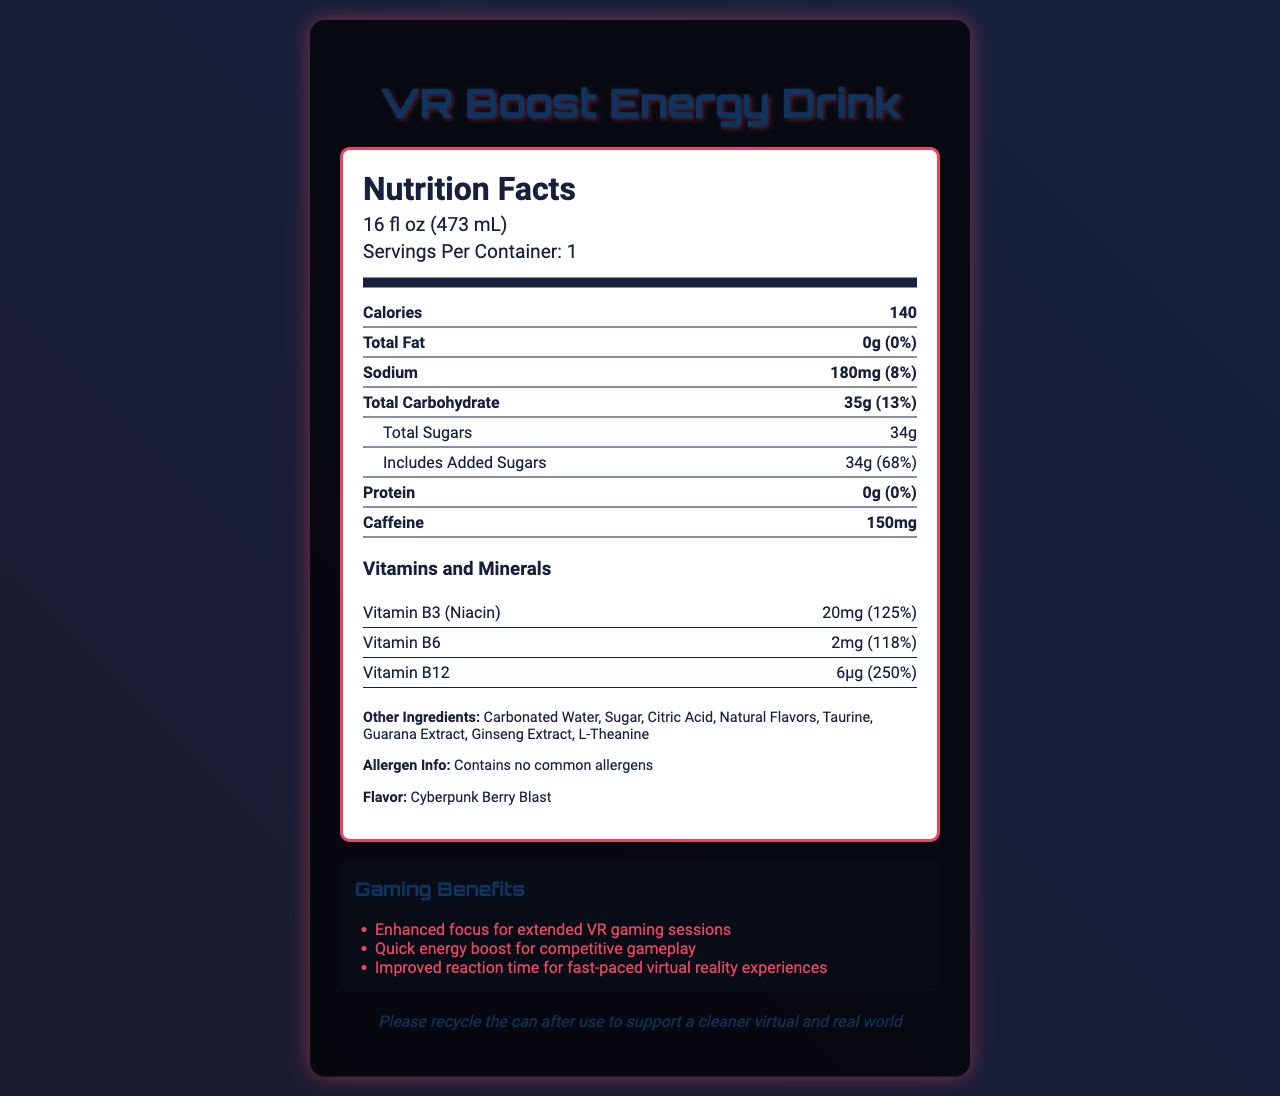who is the manufacturer of VR Boost Energy Drink? The document does not provide information about the manufacturer of the VR Boost Energy Drink.
Answer: Cannot be determined What is the primary benefit of the B-vitamins in this drink? The document claims that the drink provides enhanced focus and quick energy boost, which are often benefits associated with B-vitamins.
Answer: Enhanced focus and energy boost What is the serving size of the VR Boost Energy Drink? The serving size of the VR Boost Energy Drink is 16 fl oz (473 mL), as stated in the document.
Answer: 16 fl oz (473 mL) How many calories does one serving of VR Boost Energy Drink contain? Each serving of the VR Boost Energy Drink contains 140 calories, as indicated in the document.
Answer: 140 calories How many grams of total sugars are in one serving? The document shows that there are 34 grams of total sugars in one serving.
Answer: 34 grams Which ingredient is not present in the energy drink? A. Citric Acid B. L-Theanine C. Aspartame D. Taurine Aspartame is not listed among the other ingredients of the VR Boost Energy Drink in the document.
Answer: C What is the total amount of added sugars in the drink? A. 24g B. 26g C. 34g D. 38g The total amount of added sugars in the drink is 34g, as indicated in the document.
Answer: C Does the VR Boost Energy Drink contain any protein? The document states that the drink contains 0g of protein.
Answer: No Does the drink contain any allergens? According to the document, the VR Boost Energy Drink contains no common allergens.
Answer: No What is the main flavor profile of the VR Boost Energy Drink? The flavor profile of the drink is Cyberpunk Berry Blast.
Answer: Cyberpunk Berry Blast What are the gaming benefits highlighted for this energy drink? The document highlights the gaming benefits of enhanced focus for extended VR gaming sessions, quick energy boost for competitive gameplay, and improved reaction time for fast-paced virtual reality experiences.
Answer: Enhanced focus, quick energy boost, improved reaction time How much caffeine is in a serving of this drink? There are 150mg of caffeine in each serving of the VR Boost Energy Drink.
Answer: 150mg Summarize the key nutritional aspects of VR Boost Energy Drink. This summary consolidates the nutritional information and key highlights from the document.
Answer: The VR Boost Energy Drink contains 140 calories per serving with 0g total fat, 180mg sodium, 35g total carbohydrates (including 34g total sugars and 34g added sugars), 0g protein, and 150mg caffeine. It is also fortified with vitamins B3, B6, and B12 and contains no common allergens. The flavor profile is Cyberpunk Berry Blast, and it is designed to enhance focus and reaction time for gamers. What is the daily value percentage of Vitamin B12 in the drink? The daily value percentage of Vitamin B12 in the drink is 250% as stated in the document.
Answer: 250% 